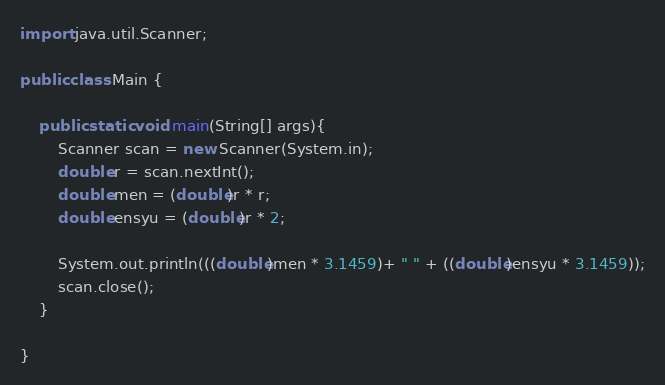Convert code to text. <code><loc_0><loc_0><loc_500><loc_500><_Java_>import java.util.Scanner;

public class Main {

    public static void main(String[] args){
		Scanner scan = new Scanner(System.in);
		double r = scan.nextInt();
		double men = (double)r * r;
		double ensyu = (double)r * 2;

		System.out.println(((double)men * 3.1459)+ " " + ((double)ensyu * 3.1459));
        scan.close();
    }

}</code> 